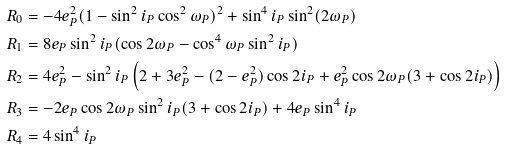<formula> <loc_0><loc_0><loc_500><loc_500>R _ { 0 } & = - 4 e _ { P } ^ { 2 } ( 1 - \sin ^ { 2 } i _ { P } \cos ^ { 2 } \omega _ { P } ) ^ { 2 } + \sin ^ { 4 } i _ { P } \sin ^ { 2 } ( 2 \omega _ { P } ) \\ R _ { 1 } & = 8 e _ { P } \sin ^ { 2 } i _ { P } ( \cos 2 \omega _ { P } - \cos ^ { 4 } \omega _ { P } \sin ^ { 2 } i _ { P } ) \\ R _ { 2 } & = 4 e _ { P } ^ { 2 } - \sin ^ { 2 } i _ { P } \left ( 2 + 3 e _ { P } ^ { 2 } - ( 2 - e _ { P } ^ { 2 } ) \cos 2 i _ { P } + e _ { P } ^ { 2 } \cos 2 \omega _ { P } ( 3 + \cos 2 i _ { P } ) \right ) \\ R _ { 3 } & = - 2 e _ { P } \cos 2 \omega _ { P } \sin ^ { 2 } i _ { P } ( 3 + \cos 2 i _ { P } ) + 4 e _ { P } \sin ^ { 4 } i _ { P } \\ R _ { 4 } & = 4 \sin ^ { 4 } i _ { P }</formula> 